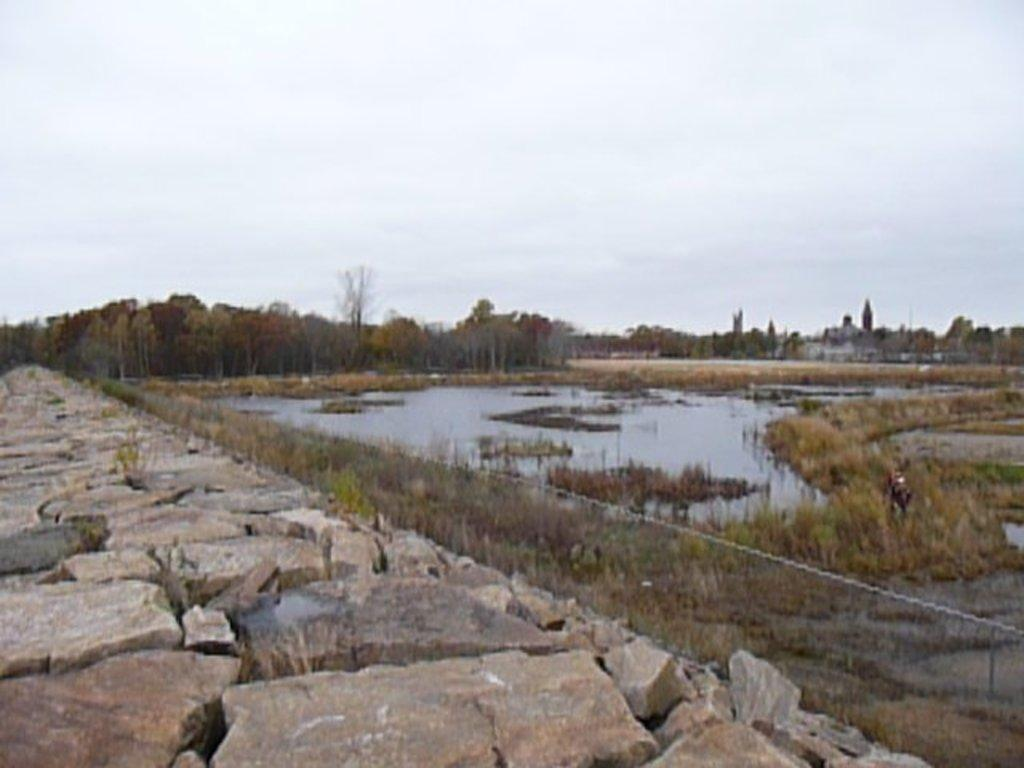What is the primary element visible in the image? There is water in the image. What type of vegetation can be seen near the water? There is dried grass in the image. What can be seen in the background of the image? There are green trees and dried trees in the background of the image. What is the color of the sky in the image? The sky is white in color. Can you see a skate being used on the dried grass in the image? There is no skate present in the image, and the dried grass does not suggest any activity involving a skate. 